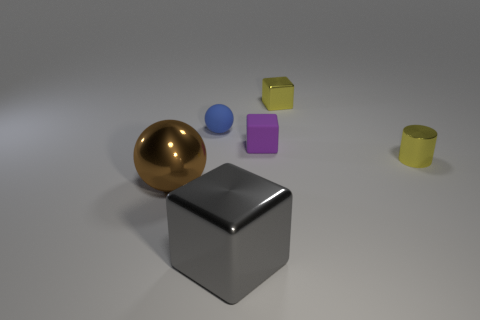Subtract all small blocks. How many blocks are left? 1 Subtract all gray cubes. How many cubes are left? 2 Subtract all cylinders. How many objects are left? 5 Subtract 1 balls. How many balls are left? 1 Subtract all small red cylinders. Subtract all yellow shiny cylinders. How many objects are left? 5 Add 2 big brown things. How many big brown things are left? 3 Add 5 small green cubes. How many small green cubes exist? 5 Add 1 small blue metallic cylinders. How many objects exist? 7 Subtract 0 blue cylinders. How many objects are left? 6 Subtract all red cubes. Subtract all red spheres. How many cubes are left? 3 